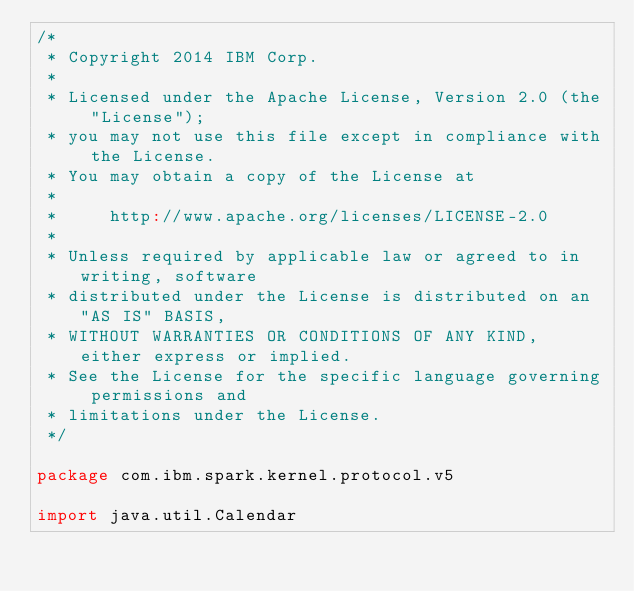<code> <loc_0><loc_0><loc_500><loc_500><_Scala_>/*
 * Copyright 2014 IBM Corp.
 *
 * Licensed under the Apache License, Version 2.0 (the "License");
 * you may not use this file except in compliance with the License.
 * You may obtain a copy of the License at
 *
 *     http://www.apache.org/licenses/LICENSE-2.0
 *
 * Unless required by applicable law or agreed to in writing, software
 * distributed under the License is distributed on an "AS IS" BASIS,
 * WITHOUT WARRANTIES OR CONDITIONS OF ANY KIND, either express or implied.
 * See the License for the specific language governing permissions and
 * limitations under the License.
 */

package com.ibm.spark.kernel.protocol.v5

import java.util.Calendar
</code> 